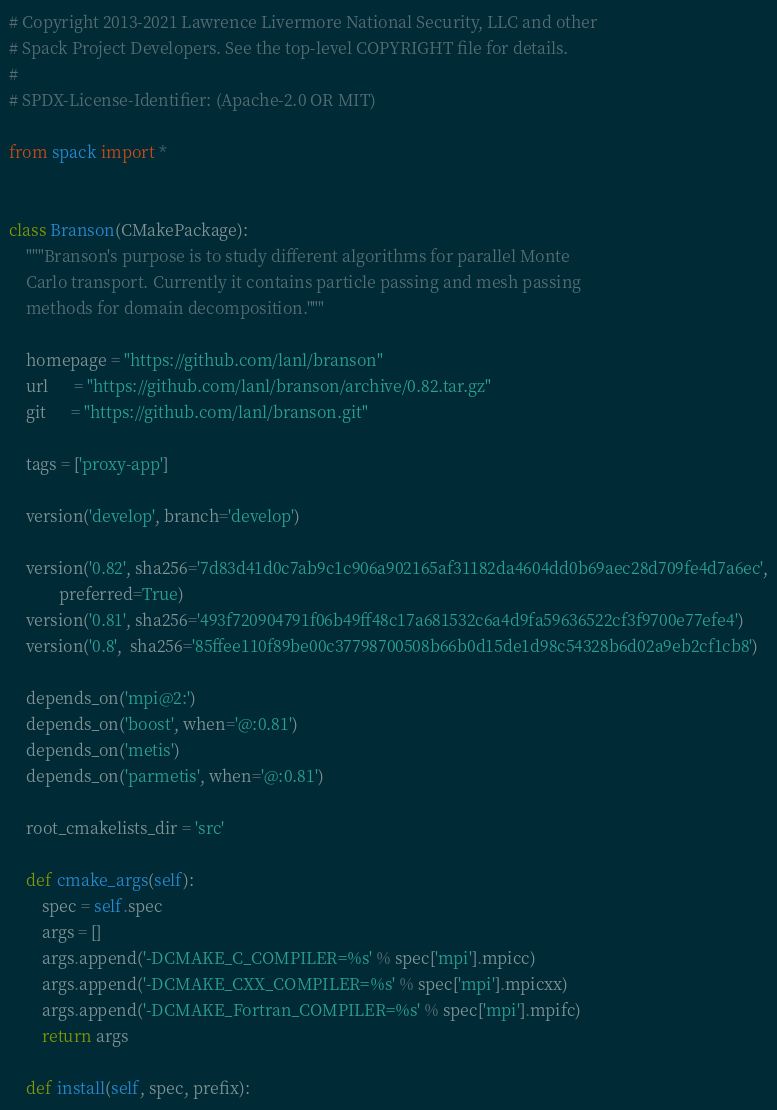<code> <loc_0><loc_0><loc_500><loc_500><_Python_># Copyright 2013-2021 Lawrence Livermore National Security, LLC and other
# Spack Project Developers. See the top-level COPYRIGHT file for details.
#
# SPDX-License-Identifier: (Apache-2.0 OR MIT)

from spack import *


class Branson(CMakePackage):
    """Branson's purpose is to study different algorithms for parallel Monte
    Carlo transport. Currently it contains particle passing and mesh passing
    methods for domain decomposition."""

    homepage = "https://github.com/lanl/branson"
    url      = "https://github.com/lanl/branson/archive/0.82.tar.gz"
    git      = "https://github.com/lanl/branson.git"

    tags = ['proxy-app']

    version('develop', branch='develop')

    version('0.82', sha256='7d83d41d0c7ab9c1c906a902165af31182da4604dd0b69aec28d709fe4d7a6ec',
            preferred=True)
    version('0.81', sha256='493f720904791f06b49ff48c17a681532c6a4d9fa59636522cf3f9700e77efe4')
    version('0.8',  sha256='85ffee110f89be00c37798700508b66b0d15de1d98c54328b6d02a9eb2cf1cb8')

    depends_on('mpi@2:')
    depends_on('boost', when='@:0.81')
    depends_on('metis')
    depends_on('parmetis', when='@:0.81')

    root_cmakelists_dir = 'src'

    def cmake_args(self):
        spec = self.spec
        args = []
        args.append('-DCMAKE_C_COMPILER=%s' % spec['mpi'].mpicc)
        args.append('-DCMAKE_CXX_COMPILER=%s' % spec['mpi'].mpicxx)
        args.append('-DCMAKE_Fortran_COMPILER=%s' % spec['mpi'].mpifc)
        return args

    def install(self, spec, prefix):</code> 